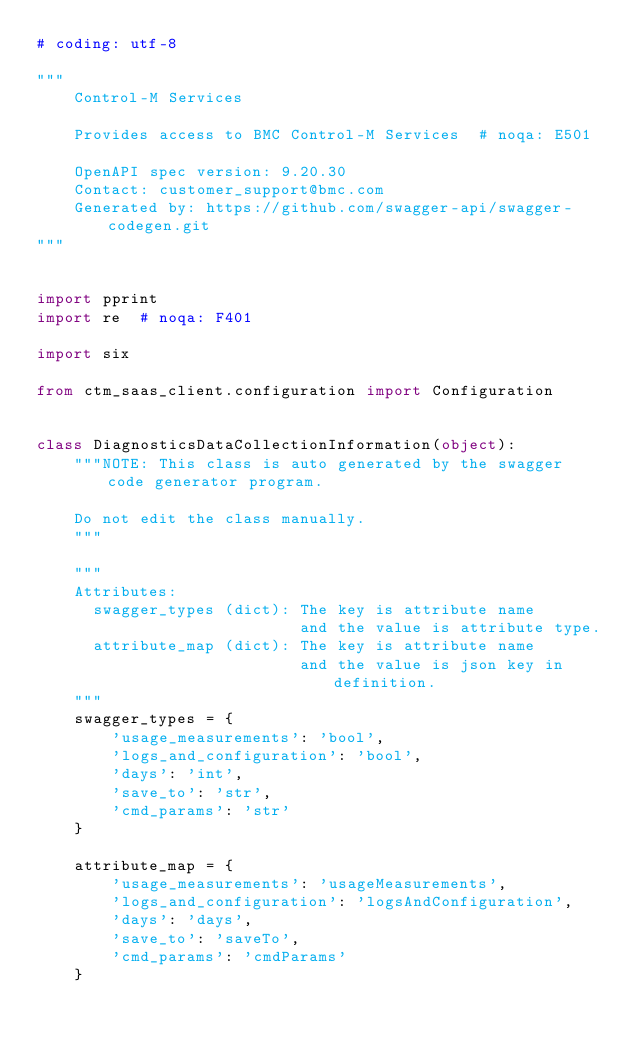Convert code to text. <code><loc_0><loc_0><loc_500><loc_500><_Python_># coding: utf-8

"""
    Control-M Services

    Provides access to BMC Control-M Services  # noqa: E501

    OpenAPI spec version: 9.20.30
    Contact: customer_support@bmc.com
    Generated by: https://github.com/swagger-api/swagger-codegen.git
"""


import pprint
import re  # noqa: F401

import six

from ctm_saas_client.configuration import Configuration


class DiagnosticsDataCollectionInformation(object):
    """NOTE: This class is auto generated by the swagger code generator program.

    Do not edit the class manually.
    """

    """
    Attributes:
      swagger_types (dict): The key is attribute name
                            and the value is attribute type.
      attribute_map (dict): The key is attribute name
                            and the value is json key in definition.
    """
    swagger_types = {
        'usage_measurements': 'bool',
        'logs_and_configuration': 'bool',
        'days': 'int',
        'save_to': 'str',
        'cmd_params': 'str'
    }

    attribute_map = {
        'usage_measurements': 'usageMeasurements',
        'logs_and_configuration': 'logsAndConfiguration',
        'days': 'days',
        'save_to': 'saveTo',
        'cmd_params': 'cmdParams'
    }
</code> 